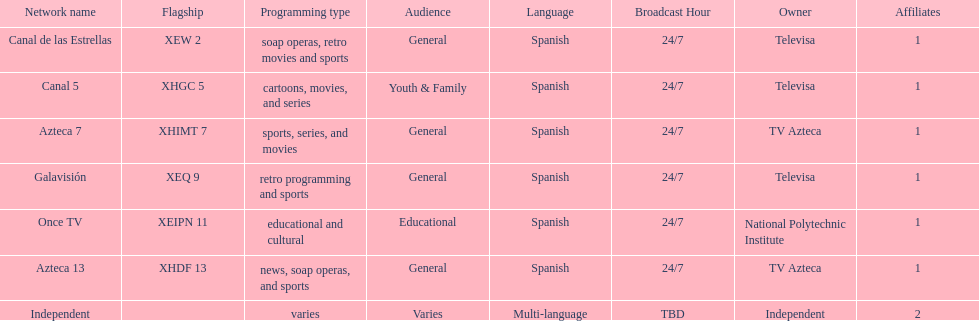How many networks does tv azteca own? 2. 